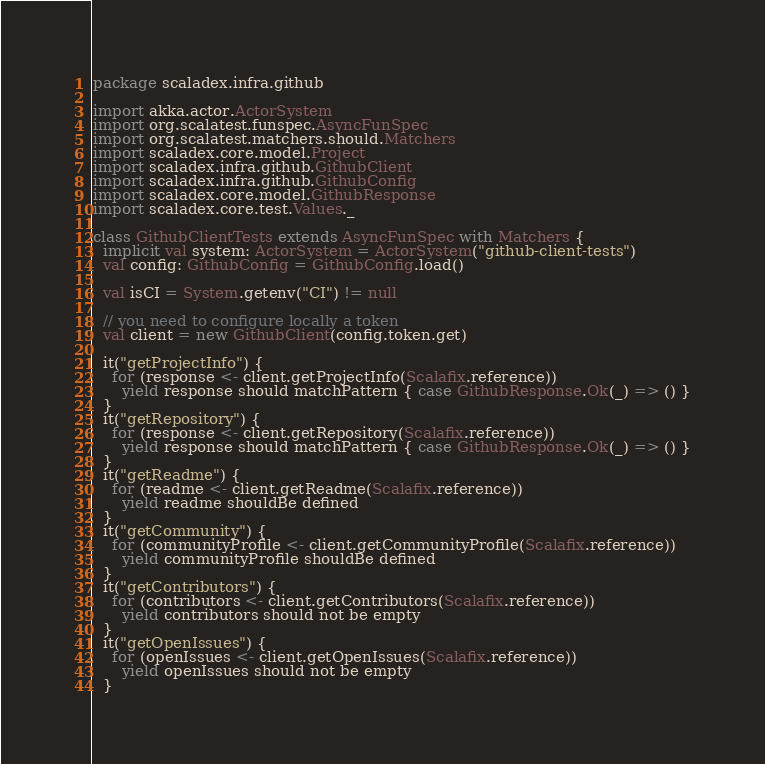<code> <loc_0><loc_0><loc_500><loc_500><_Scala_>package scaladex.infra.github

import akka.actor.ActorSystem
import org.scalatest.funspec.AsyncFunSpec
import org.scalatest.matchers.should.Matchers
import scaladex.core.model.Project
import scaladex.infra.github.GithubClient
import scaladex.infra.github.GithubConfig
import scaladex.core.model.GithubResponse
import scaladex.core.test.Values._

class GithubClientTests extends AsyncFunSpec with Matchers {
  implicit val system: ActorSystem = ActorSystem("github-client-tests")
  val config: GithubConfig = GithubConfig.load()

  val isCI = System.getenv("CI") != null

  // you need to configure locally a token
  val client = new GithubClient(config.token.get)

  it("getProjectInfo") {
    for (response <- client.getProjectInfo(Scalafix.reference))
      yield response should matchPattern { case GithubResponse.Ok(_) => () }
  }
  it("getRepository") {
    for (response <- client.getRepository(Scalafix.reference))
      yield response should matchPattern { case GithubResponse.Ok(_) => () }
  }
  it("getReadme") {
    for (readme <- client.getReadme(Scalafix.reference))
      yield readme shouldBe defined
  }
  it("getCommunity") {
    for (communityProfile <- client.getCommunityProfile(Scalafix.reference))
      yield communityProfile shouldBe defined
  }
  it("getContributors") {
    for (contributors <- client.getContributors(Scalafix.reference))
      yield contributors should not be empty
  }
  it("getOpenIssues") {
    for (openIssues <- client.getOpenIssues(Scalafix.reference))
      yield openIssues should not be empty
  }</code> 